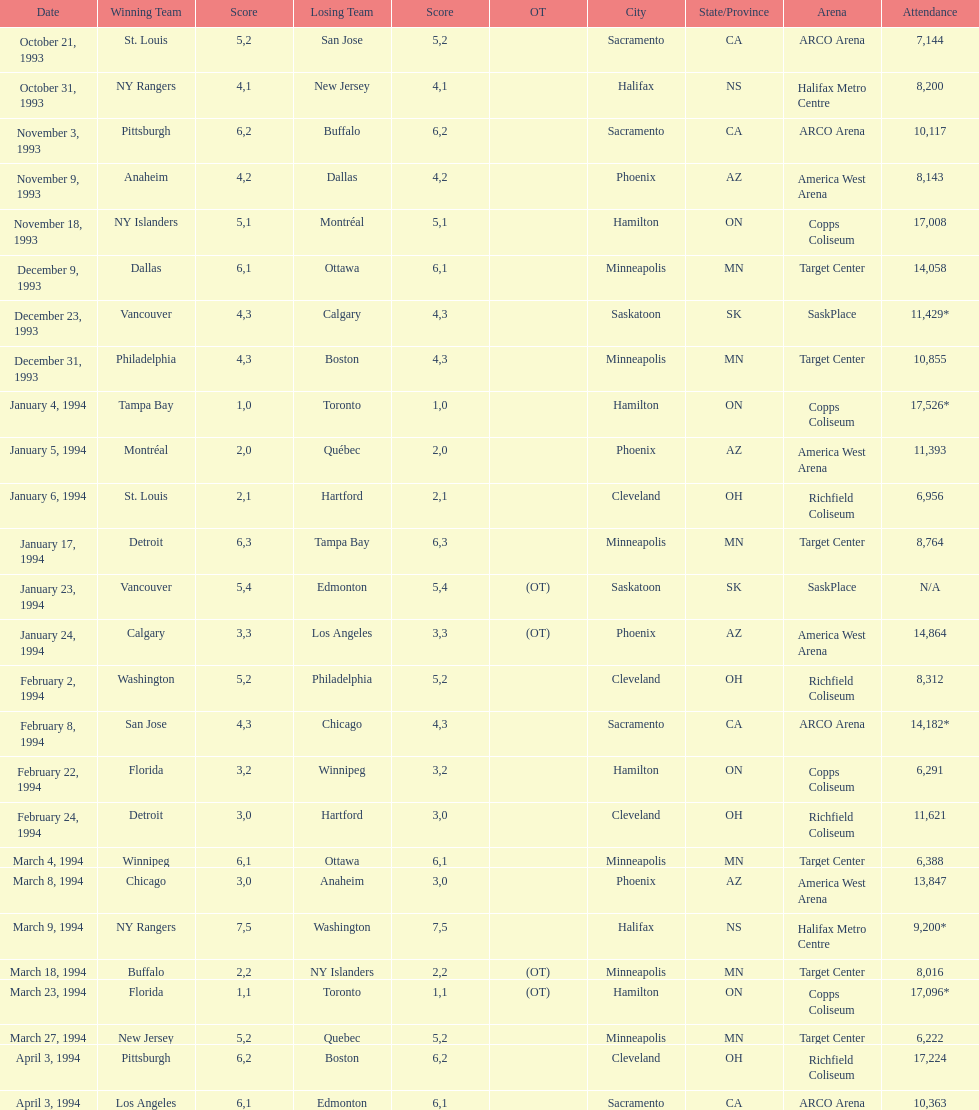How many events occurred in minneapolis, mn? 6. 